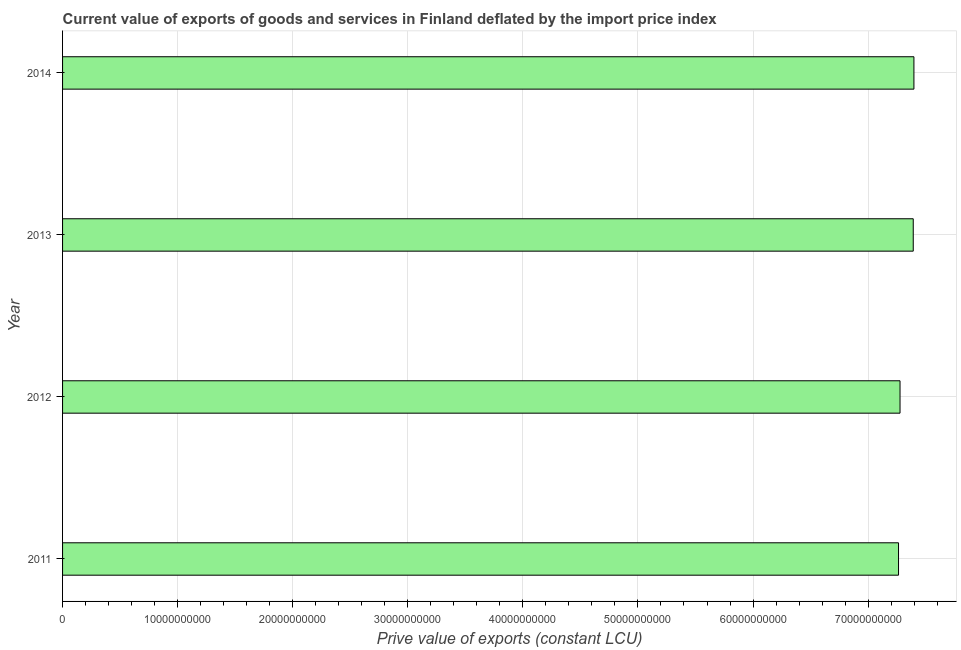Does the graph contain any zero values?
Provide a short and direct response. No. What is the title of the graph?
Provide a short and direct response. Current value of exports of goods and services in Finland deflated by the import price index. What is the label or title of the X-axis?
Give a very brief answer. Prive value of exports (constant LCU). What is the price value of exports in 2011?
Ensure brevity in your answer.  7.26e+1. Across all years, what is the maximum price value of exports?
Keep it short and to the point. 7.40e+1. Across all years, what is the minimum price value of exports?
Keep it short and to the point. 7.26e+1. In which year was the price value of exports minimum?
Your response must be concise. 2011. What is the sum of the price value of exports?
Your answer should be very brief. 2.93e+11. What is the difference between the price value of exports in 2011 and 2012?
Offer a very short reply. -1.30e+08. What is the average price value of exports per year?
Offer a terse response. 7.33e+1. What is the median price value of exports?
Provide a succinct answer. 7.33e+1. Is the difference between the price value of exports in 2011 and 2012 greater than the difference between any two years?
Keep it short and to the point. No. What is the difference between the highest and the second highest price value of exports?
Provide a succinct answer. 5.85e+07. Is the sum of the price value of exports in 2011 and 2014 greater than the maximum price value of exports across all years?
Offer a terse response. Yes. What is the difference between the highest and the lowest price value of exports?
Your response must be concise. 1.34e+09. In how many years, is the price value of exports greater than the average price value of exports taken over all years?
Your response must be concise. 2. How many bars are there?
Provide a short and direct response. 4. How many years are there in the graph?
Ensure brevity in your answer.  4. Are the values on the major ticks of X-axis written in scientific E-notation?
Provide a succinct answer. No. What is the Prive value of exports (constant LCU) of 2011?
Provide a succinct answer. 7.26e+1. What is the Prive value of exports (constant LCU) of 2012?
Your answer should be very brief. 7.28e+1. What is the Prive value of exports (constant LCU) of 2013?
Your answer should be very brief. 7.39e+1. What is the Prive value of exports (constant LCU) of 2014?
Offer a terse response. 7.40e+1. What is the difference between the Prive value of exports (constant LCU) in 2011 and 2012?
Offer a terse response. -1.30e+08. What is the difference between the Prive value of exports (constant LCU) in 2011 and 2013?
Your response must be concise. -1.28e+09. What is the difference between the Prive value of exports (constant LCU) in 2011 and 2014?
Your answer should be compact. -1.34e+09. What is the difference between the Prive value of exports (constant LCU) in 2012 and 2013?
Your answer should be compact. -1.15e+09. What is the difference between the Prive value of exports (constant LCU) in 2012 and 2014?
Ensure brevity in your answer.  -1.21e+09. What is the difference between the Prive value of exports (constant LCU) in 2013 and 2014?
Ensure brevity in your answer.  -5.85e+07. What is the ratio of the Prive value of exports (constant LCU) in 2011 to that in 2013?
Your response must be concise. 0.98. What is the ratio of the Prive value of exports (constant LCU) in 2011 to that in 2014?
Provide a succinct answer. 0.98. What is the ratio of the Prive value of exports (constant LCU) in 2012 to that in 2014?
Ensure brevity in your answer.  0.98. What is the ratio of the Prive value of exports (constant LCU) in 2013 to that in 2014?
Provide a succinct answer. 1. 